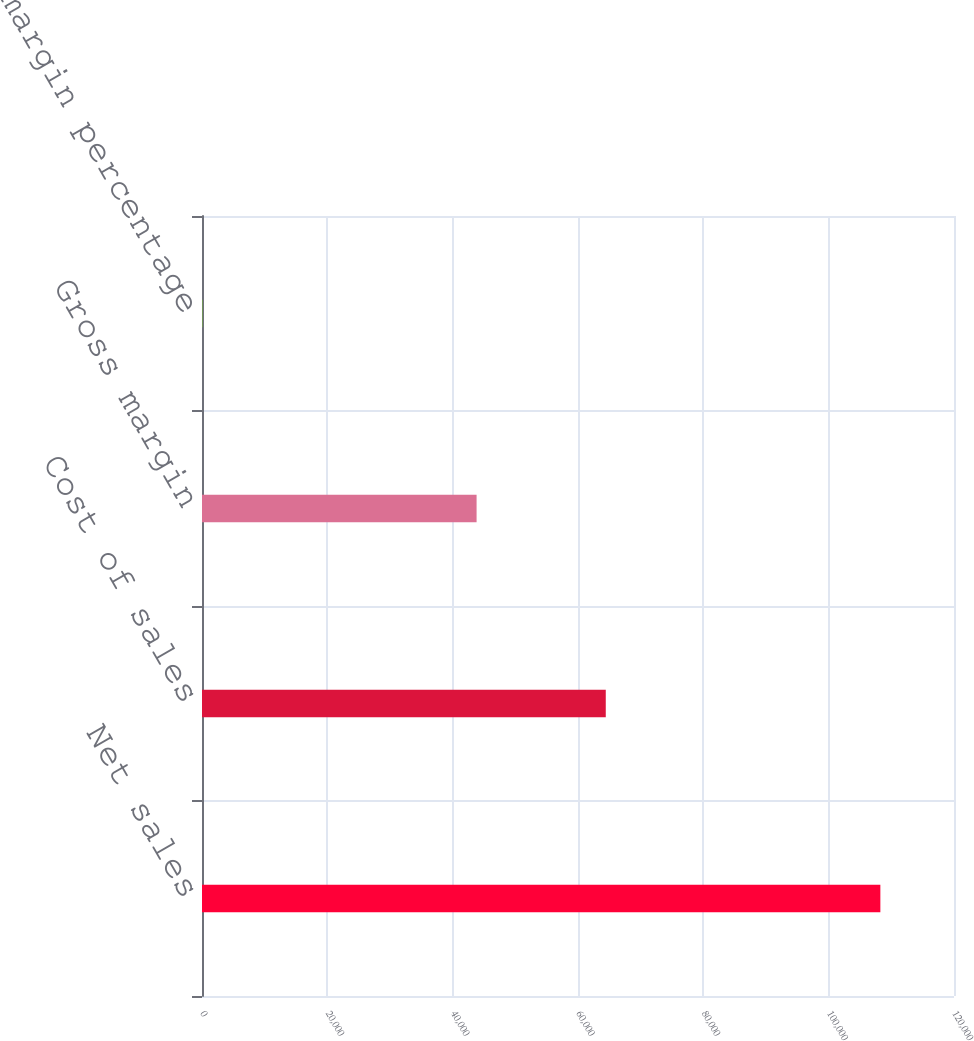Convert chart to OTSL. <chart><loc_0><loc_0><loc_500><loc_500><bar_chart><fcel>Net sales<fcel>Cost of sales<fcel>Gross margin<fcel>Gross margin percentage<nl><fcel>108249<fcel>64431<fcel>43818<fcel>40.5<nl></chart> 